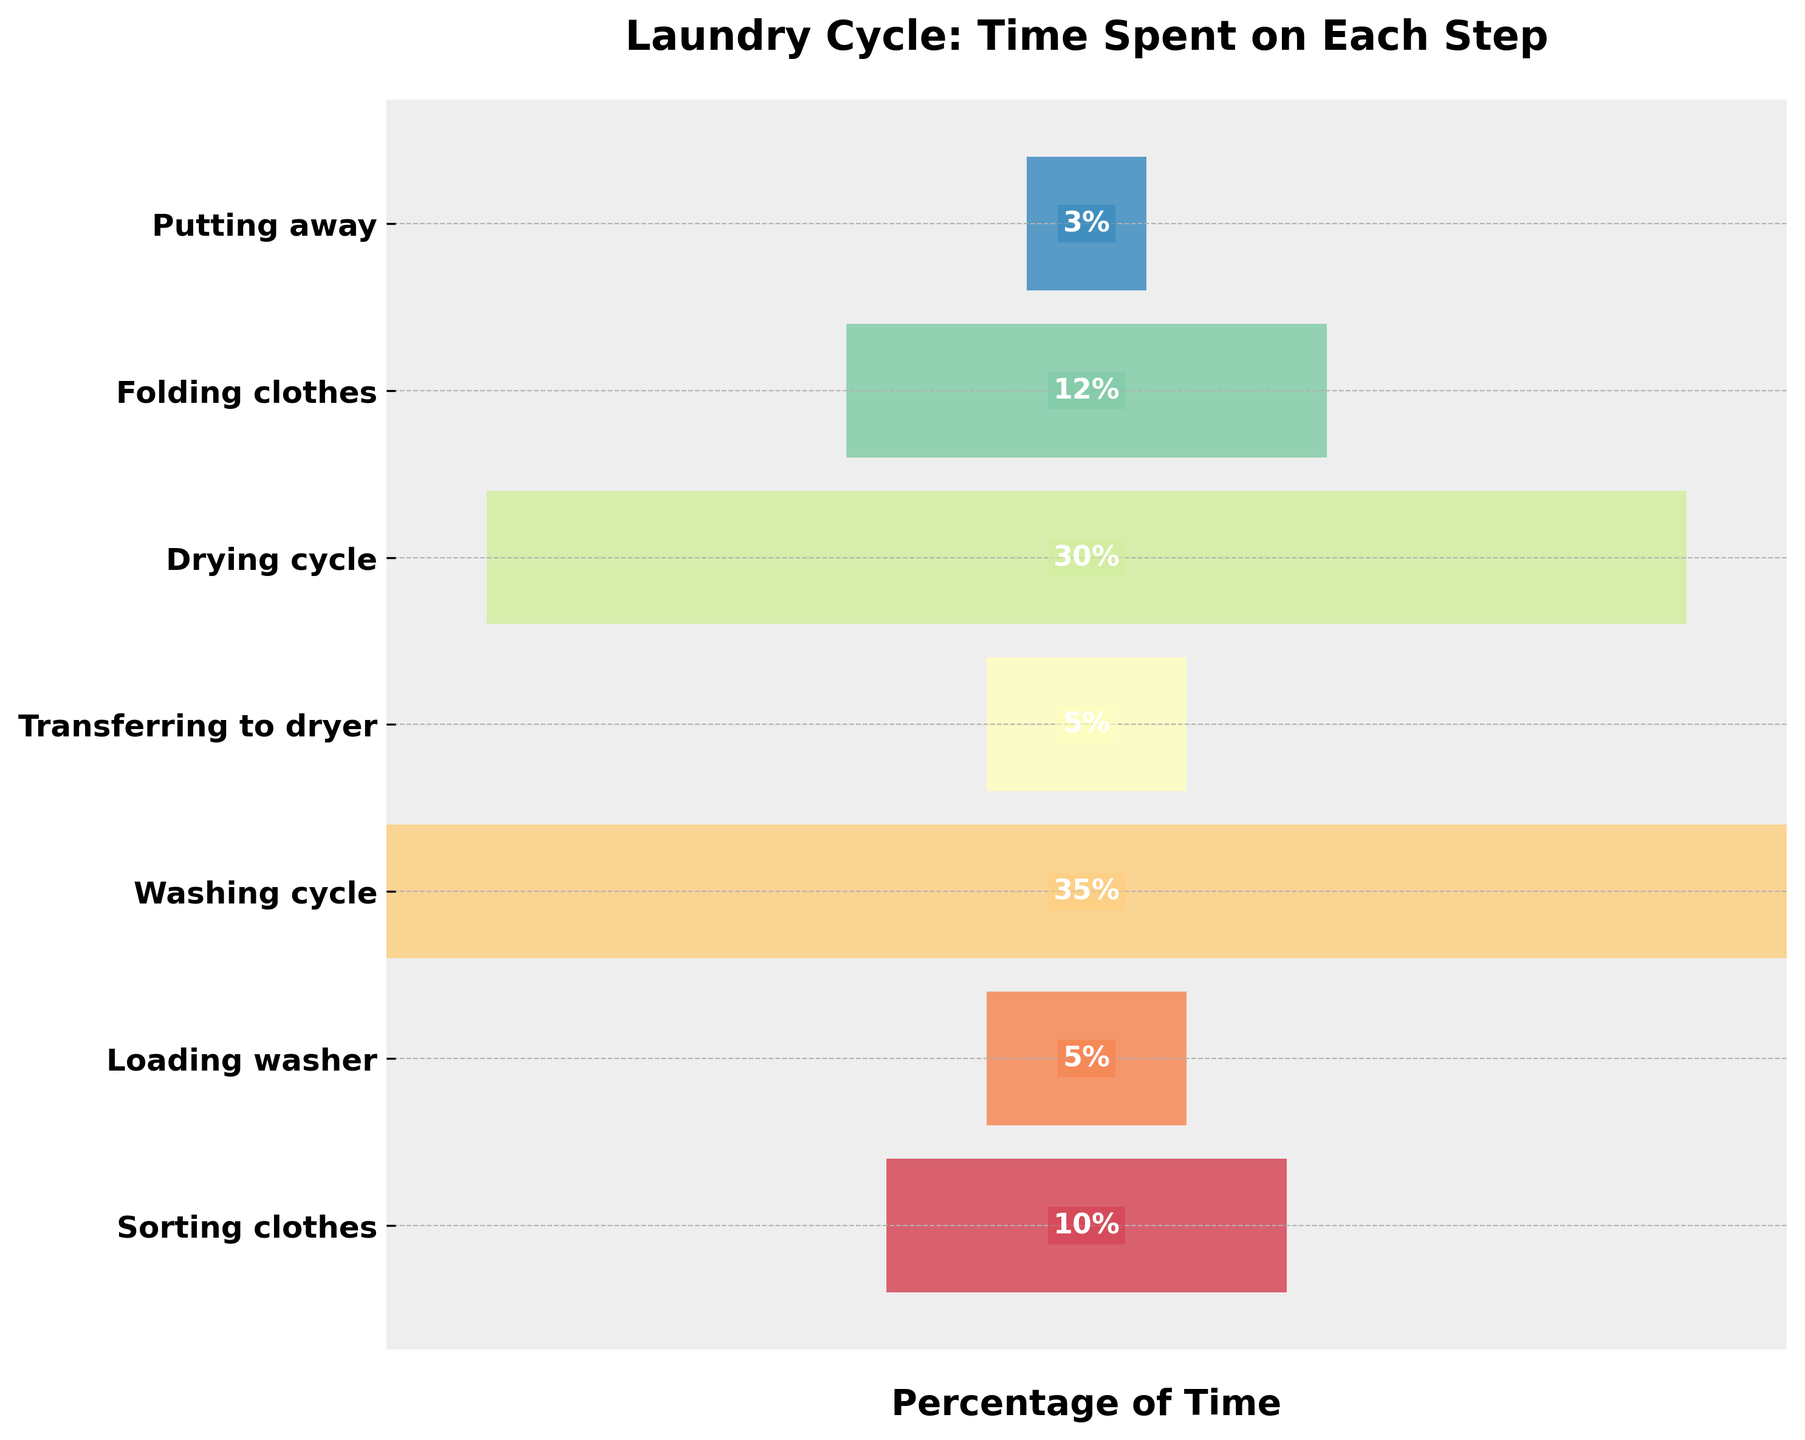What's the title of the chart? The title of the chart is written at the top of the figure and is displayed prominently.
Answer: Laundry Cycle: Time Spent on Each Step Which step takes up the most time in the laundry cycle? The step with the highest percentage value represents the step taking the most time. In this figure, it is the "Washing cycle" with 35%.
Answer: Washing cycle How much more time is spent on washing than on drying? Washing cycle is 35%, and Drying cycle is 30%. Subtract the Drying cycle time from the Washing cycle time (35% - 30%).
Answer: 5% What is the total time percentage spent on washing and drying together? Add the time percentages of both the Washing cycle and the Drying cycle. (35% + 30%).
Answer: 65% How much time is spent on steps other than sorting clothes and putting away? Subtract the percentages of Sorting clothes and Putting away from the total 100%. (100% - 10% - 3%).
Answer: 87% What are the steps that take 5% of the time? Checking the figure, "Loading washer" and "Transferring to dryer" each have a time percentage of 5%.
Answer: Loading washer and Transferring to dryer Which step takes the least amount of time? The step with the lowest percentage value represents the step taking the least time. According to the figure, it is "Putting away" with 3%.
Answer: Putting away Order the steps from the least to the most time spent. Listing the steps in ascending order of their time percentages: 3%, 5%, 5%, 10%, 12%, 30%, 35%.
Answer: Putting away, Loading washer, Transferring to dryer, Sorting clothes, Folding clothes, Drying cycle, Washing cycle 